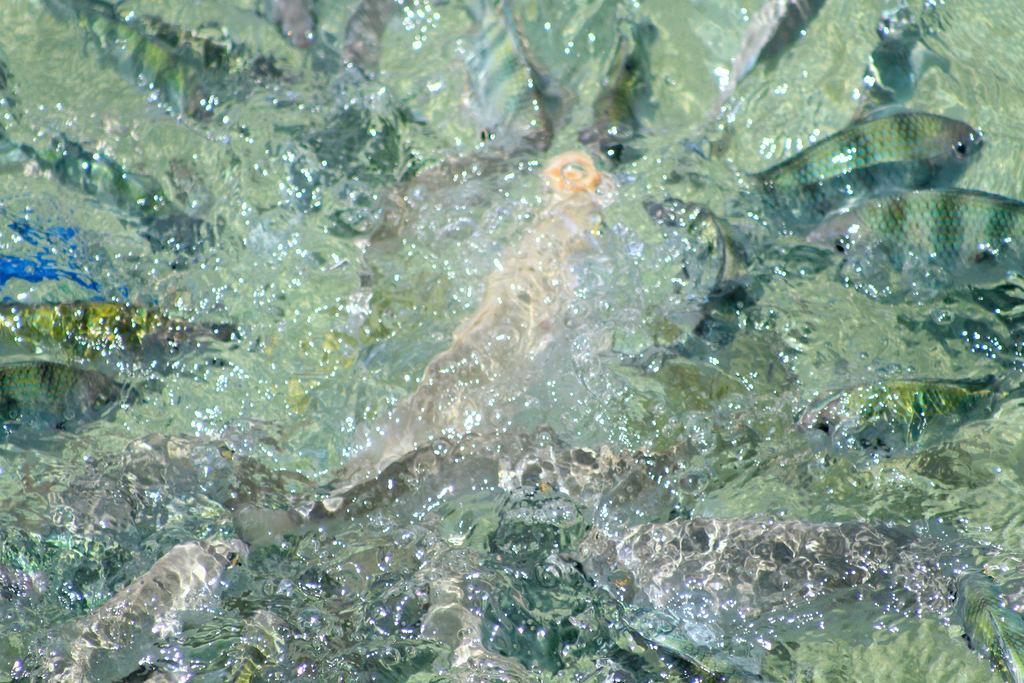Can you describe this image briefly? In this image we can see fishes in water. 